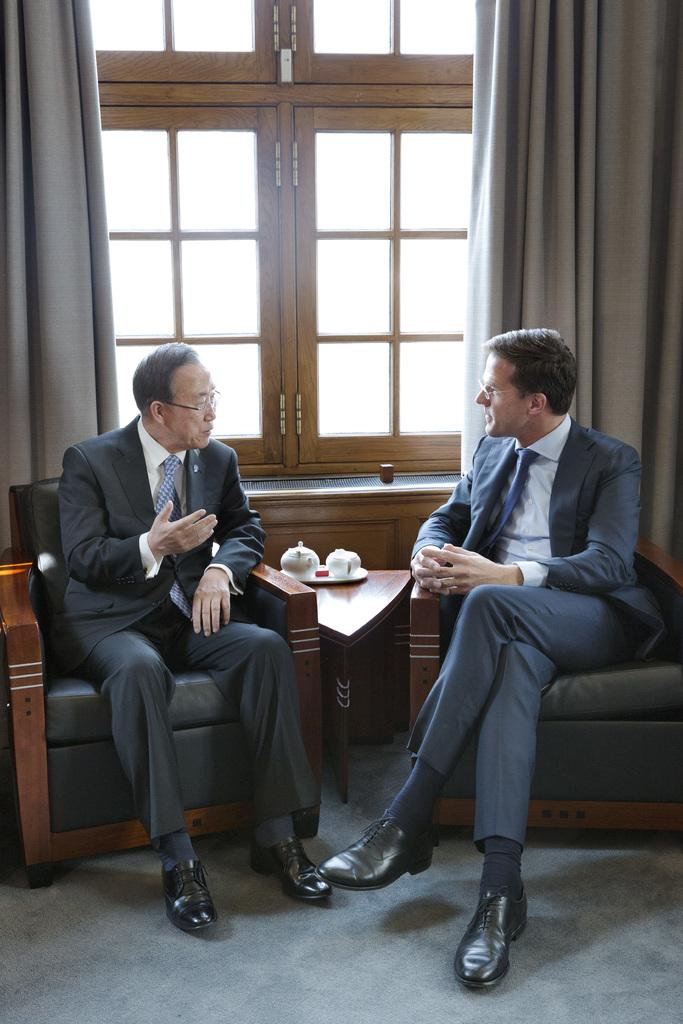How many people are in the image? There are two people in the image. What are the people doing in the image? The people are seated on chairs. What objects can be seen in the background of the image? There are tea cups in the background. What type of window treatment is visible in the image? There are curtains visible in the image. What type of rifle is being used by one of the people in the image? There is no rifle present in the image; the people are seated on chairs and there are no weapons visible. 